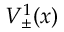<formula> <loc_0><loc_0><loc_500><loc_500>V _ { \pm } ^ { 1 } ( x )</formula> 